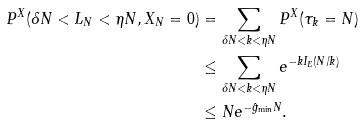<formula> <loc_0><loc_0><loc_500><loc_500>P ^ { X } ( \delta N < L _ { N } < \eta N , X _ { N } = 0 ) & = \sum _ { \delta N < k < \eta N } P ^ { X } ( \tau _ { k } = N ) \\ & \leq \sum _ { \delta N < k < \eta N } e ^ { - k I _ { E } ( N / k ) } \\ & \leq N e ^ { - \hat { g } _ { \min } N } .</formula> 